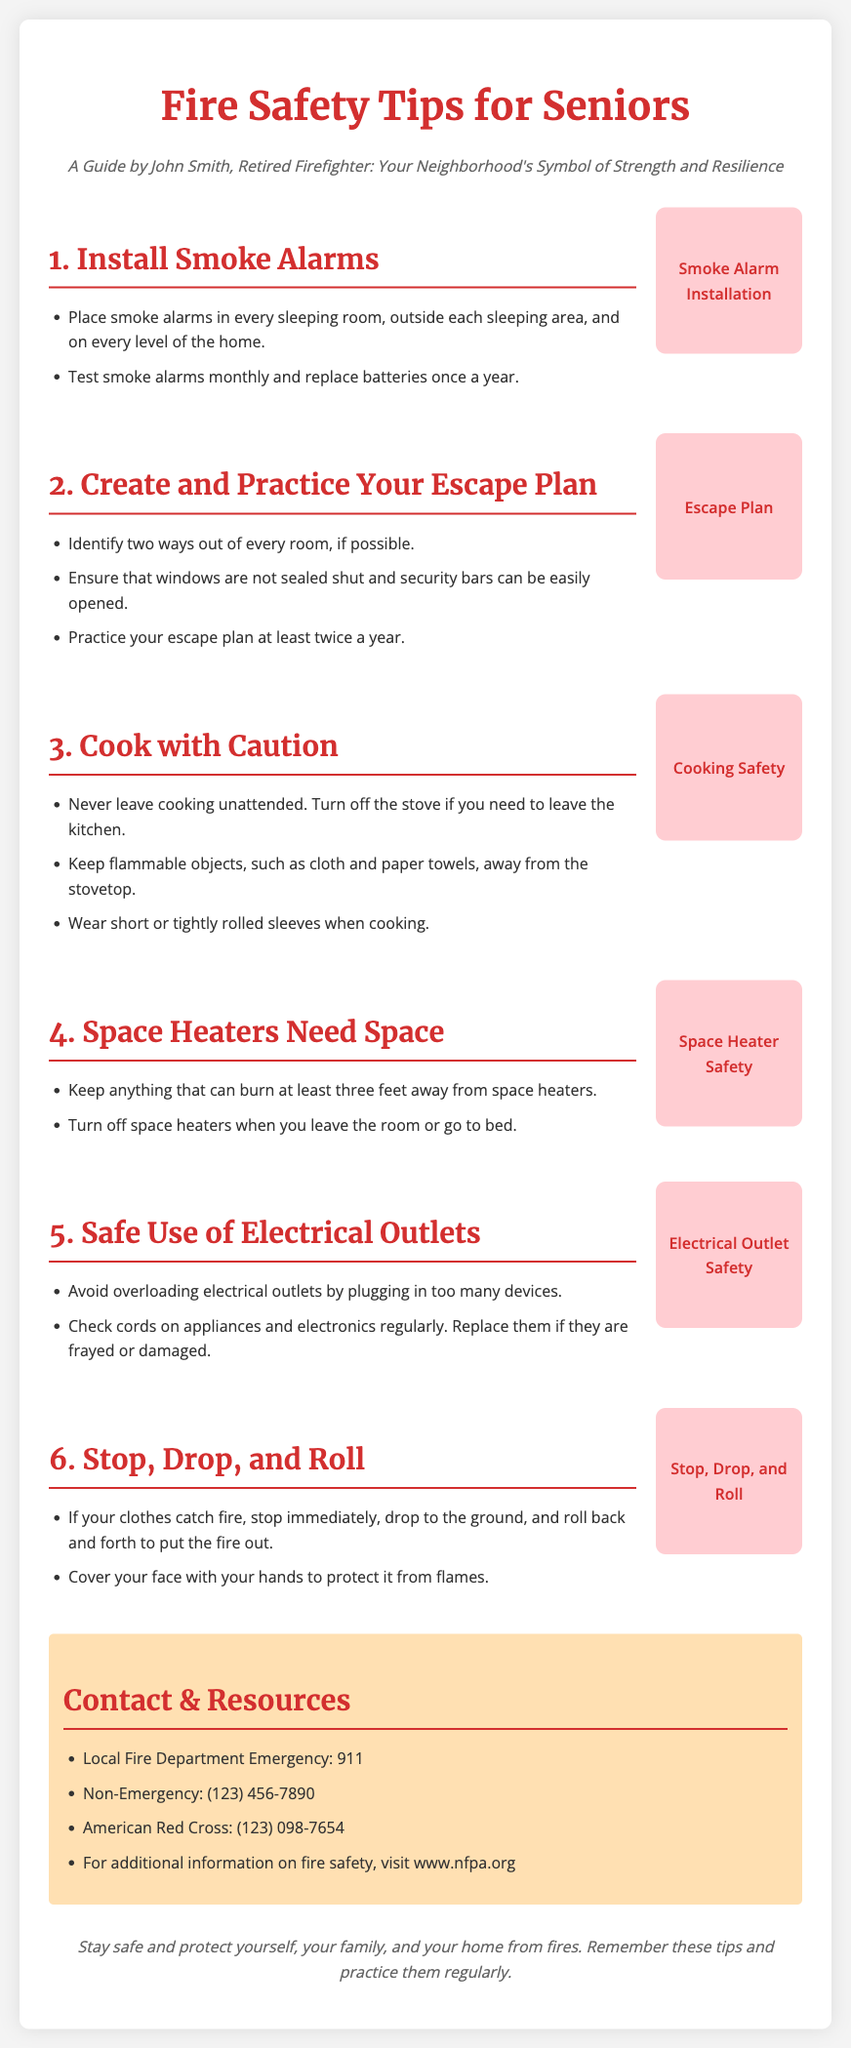What is the title of the document? The title of the document is presented prominently at the top of the page.
Answer: Fire Safety Tips for Seniors Who authored the guide? The author is mentioned in the subtitle of the document.
Answer: John Smith How often should smoke alarms be tested? The document specifies the frequency of testing smoke alarms within the relevant tip section.
Answer: Monthly What are two ways out of every room? The document suggests identifying exit strategies as part of the escape plan for safety.
Answer: Two ways What minimum distance should be kept from space heaters? The document provides safety distance recommendations for space heaters in one of the tips.
Answer: Three feet What action should be taken if clothing catches fire? The document describes emergency procedures if clothes catch fire in the relevant safety tip.
Answer: Stop, Drop, and Roll What is the contact number for the local fire department emergency? The document lists emergency contact numbers within the contact section.
Answer: 911 Where can additional fire safety information be found? The document provides a specific resource for more fire safety information towards the end.
Answer: www.nfpa.org 